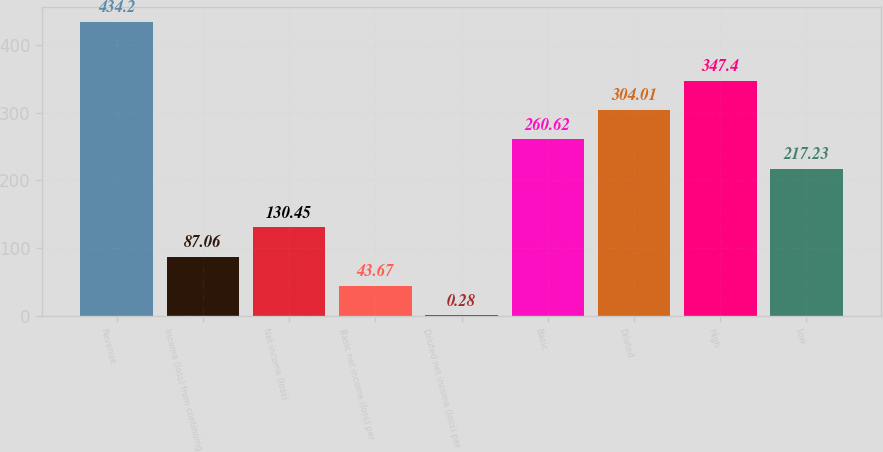Convert chart to OTSL. <chart><loc_0><loc_0><loc_500><loc_500><bar_chart><fcel>Revenue<fcel>Income (loss) from continuing<fcel>Net income (loss)<fcel>Basic net income (loss) per<fcel>Diluted net income (loss) per<fcel>Basic<fcel>Diluted<fcel>High<fcel>Low<nl><fcel>434.2<fcel>87.06<fcel>130.45<fcel>43.67<fcel>0.28<fcel>260.62<fcel>304.01<fcel>347.4<fcel>217.23<nl></chart> 